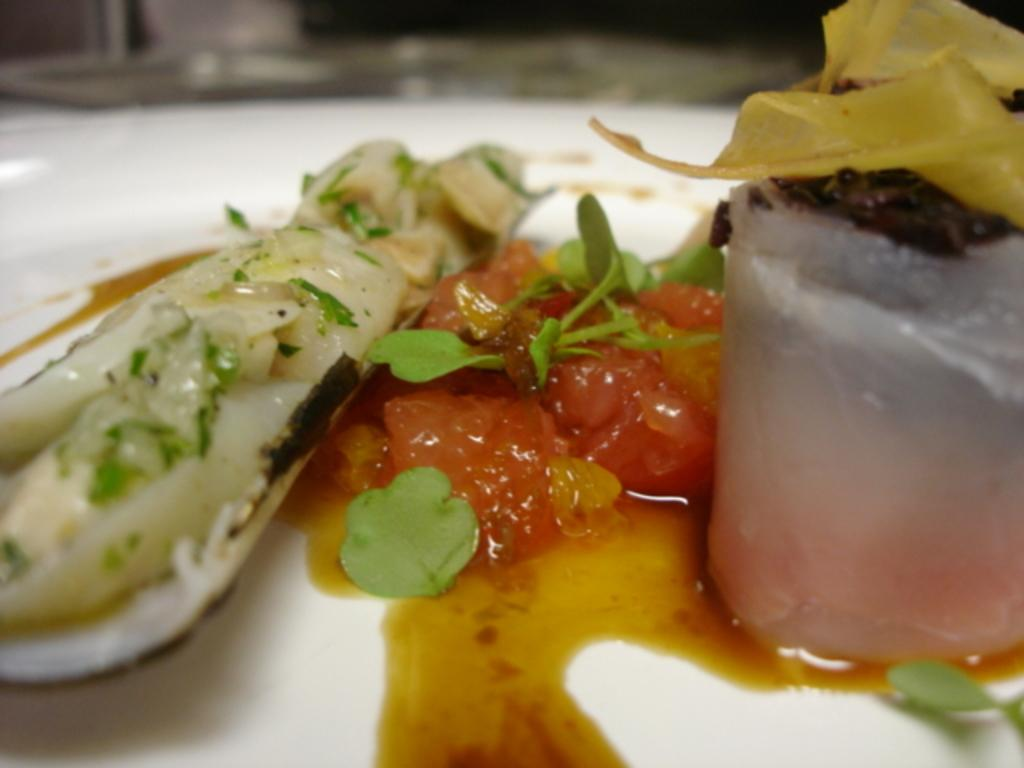What is the main subject of the image? The main subject of the image is a food item. How is the food item presented in the image? The food item is kept on a white color plate. What type of business is being conducted in the image? There is no indication of any business activity in the image; it features a food item on a white plate. What type of guide is present in the image? There is no guide present in the image; it features a food item on a white plate. 